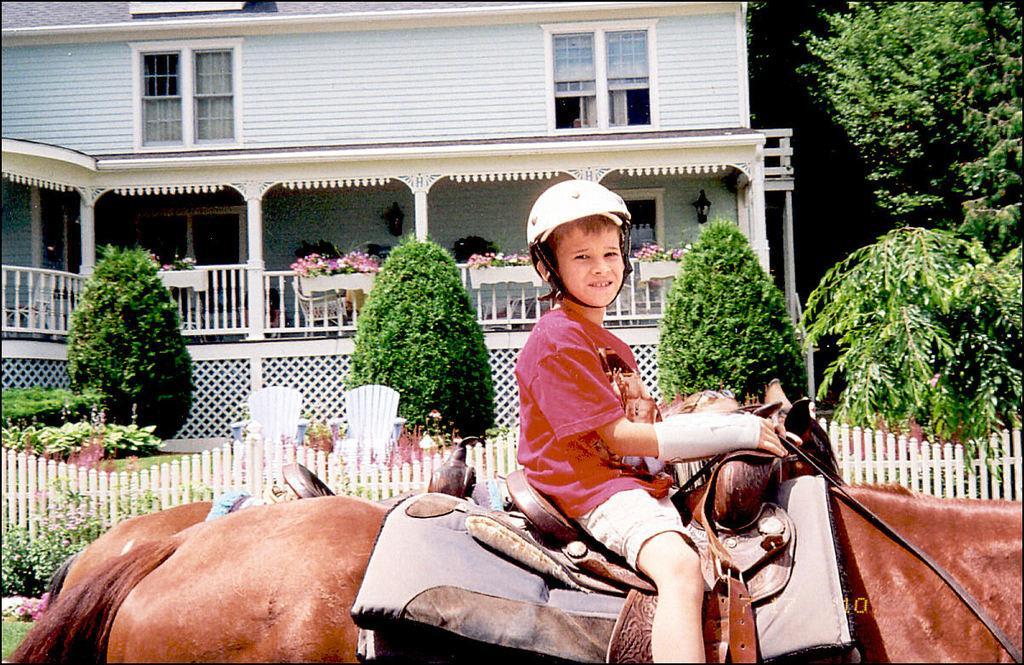In one or two sentences, can you explain what this image depicts? In this image there is a boy in the middle who is sitting on the horse. In the background there is a building. In front of the building there is a garden in which there are trees. There is a fence around the building. On the right side there are trees. 